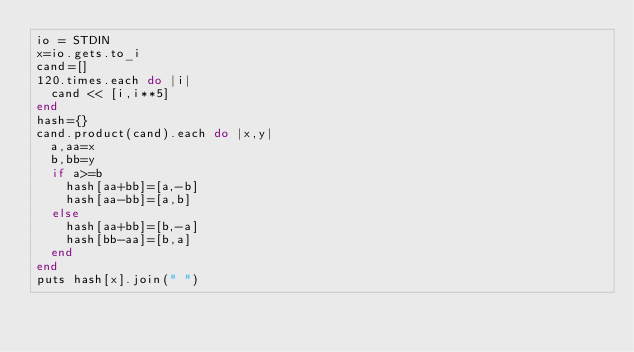<code> <loc_0><loc_0><loc_500><loc_500><_Ruby_>io = STDIN
x=io.gets.to_i
cand=[]
120.times.each do |i|
  cand << [i,i**5]
end
hash={}
cand.product(cand).each do |x,y|
  a,aa=x
  b,bb=y
  if a>=b
    hash[aa+bb]=[a,-b]
    hash[aa-bb]=[a,b]
  else
    hash[aa+bb]=[b,-a]
    hash[bb-aa]=[b,a]
  end
end
puts hash[x].join(" ")
</code> 